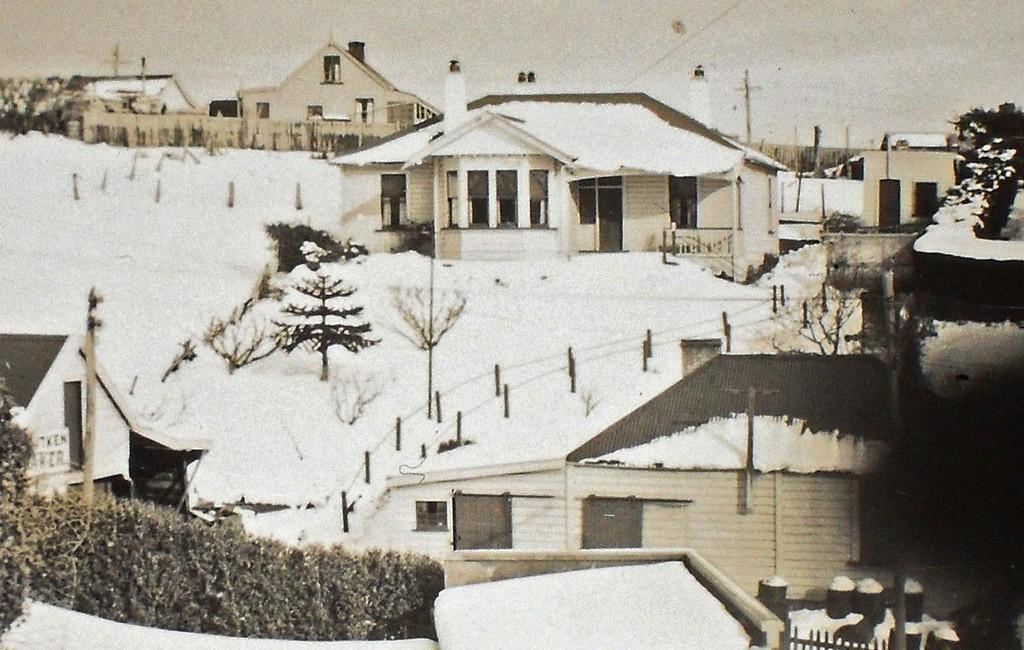What is the color scheme of the image? The image is black and white. What is the landscape like in the image? The land is covered with snow. What type of structures can be seen in the image? There are houses in the image. What other natural elements are present in the image? There are trees in the image. What man-made objects can be seen in the image? There are poles in the image. What type of marble is used to decorate the jail in the image? There is no jail present in the image, and therefore no marble can be observed. How many grapes are hanging from the trees in the image? There are no grapes present in the image, as it features a snow-covered landscape with trees. 